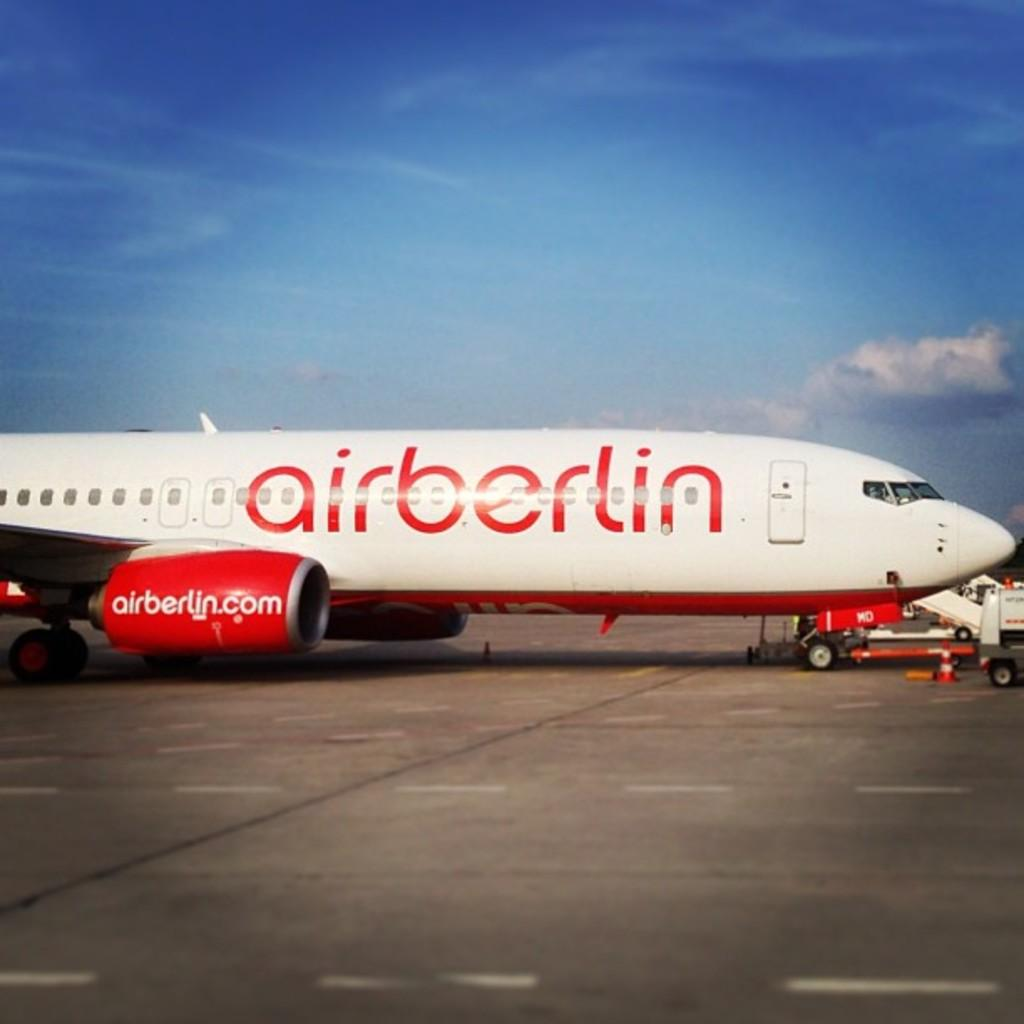<image>
Describe the image concisely. The white aircraft has airberlin written in large red letters on it. 